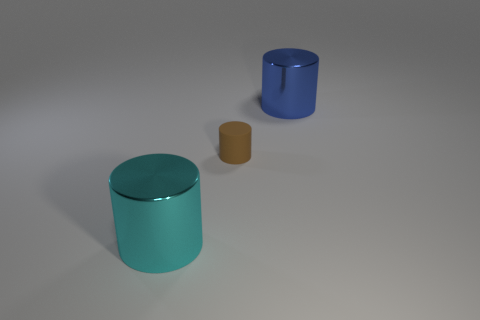Is there any other thing that is the same material as the brown cylinder?
Make the answer very short. No. What material is the large cylinder that is behind the large thing that is left of the big metallic object behind the big cyan metal thing made of?
Give a very brief answer. Metal. Does the cyan metal thing have the same shape as the large blue metallic thing?
Keep it short and to the point. Yes. How many matte things are blue things or tiny purple cubes?
Provide a succinct answer. 0. What number of large matte spheres are there?
Provide a short and direct response. 0. There is another metallic cylinder that is the same size as the cyan cylinder; what is its color?
Offer a terse response. Blue. Is the blue cylinder the same size as the cyan shiny thing?
Provide a succinct answer. Yes. Is the size of the brown cylinder the same as the metal cylinder on the left side of the small brown cylinder?
Your answer should be very brief. No. Are there more big objects behind the small cylinder than cyan metal cylinders that are to the left of the big blue shiny object?
Ensure brevity in your answer.  No. What is the size of the cyan cylinder that is made of the same material as the big blue thing?
Your response must be concise. Large. 